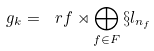<formula> <loc_0><loc_0><loc_500><loc_500>\ g _ { k } = \ r f \rtimes \bigoplus _ { f \in F } \S l _ { n _ { f } }</formula> 